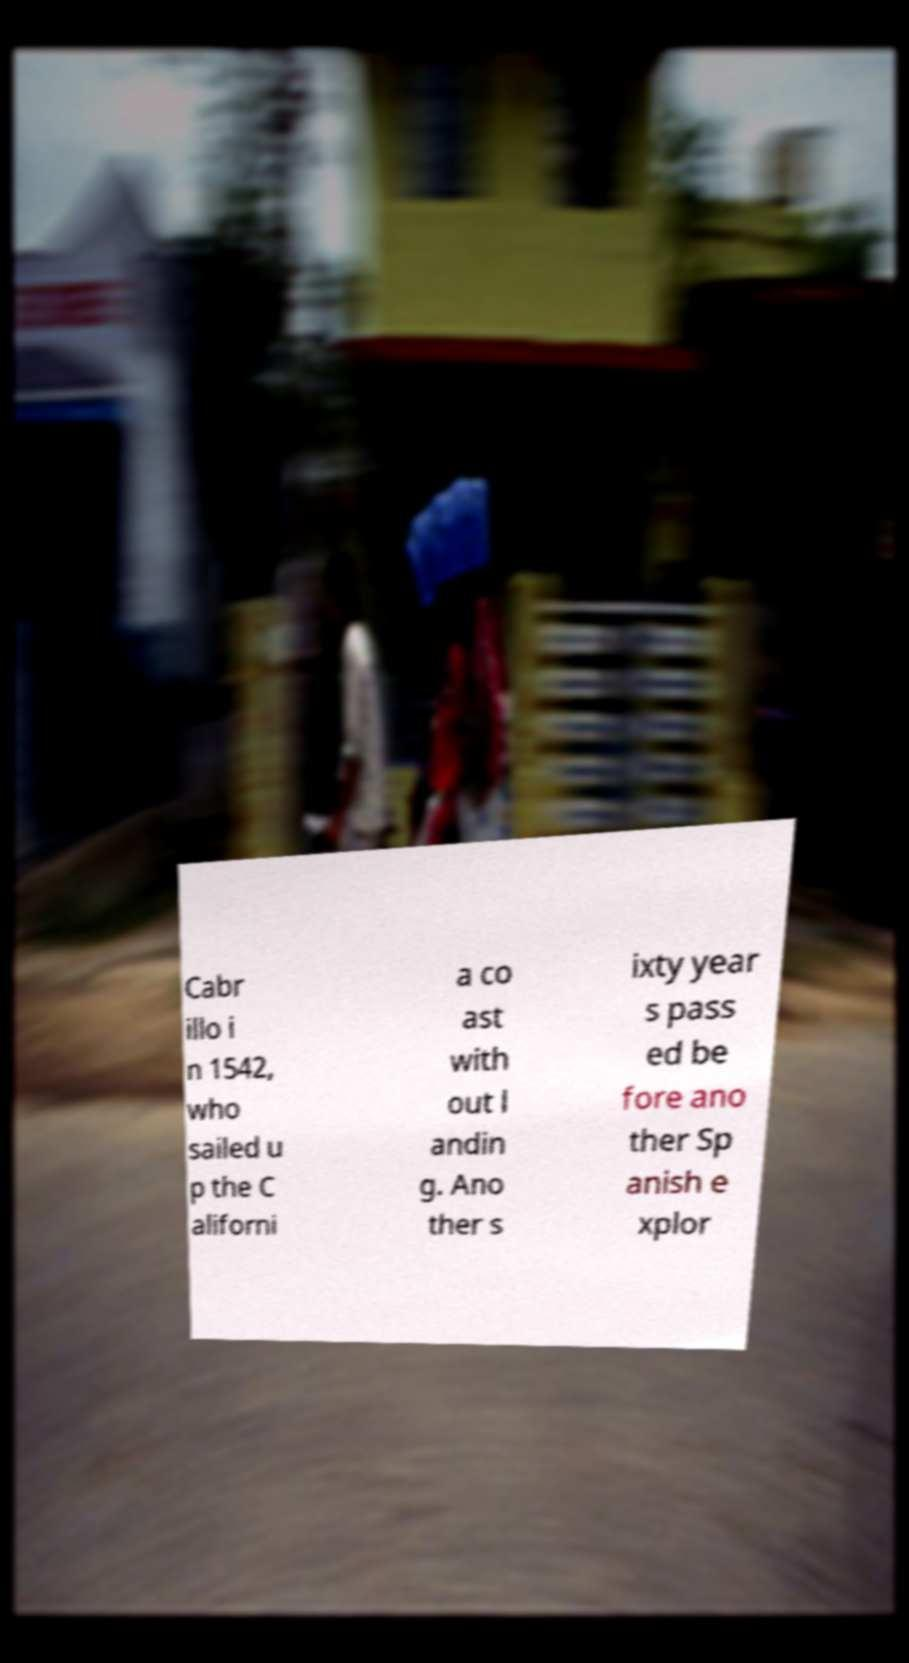Please identify and transcribe the text found in this image. Cabr illo i n 1542, who sailed u p the C aliforni a co ast with out l andin g. Ano ther s ixty year s pass ed be fore ano ther Sp anish e xplor 